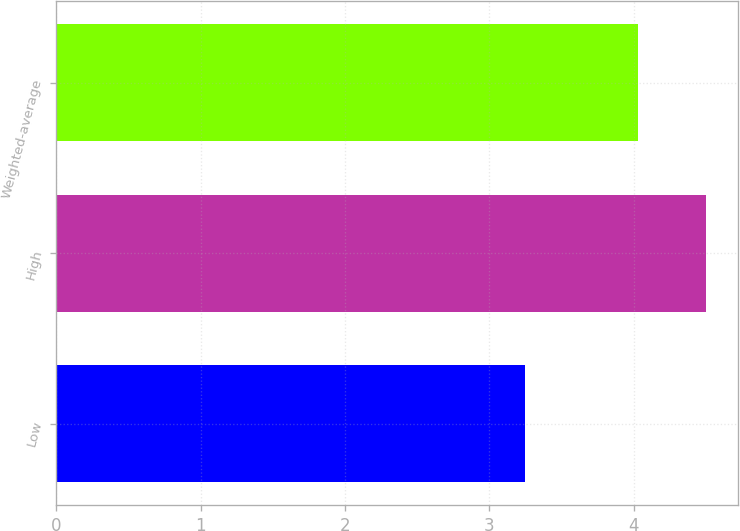Convert chart. <chart><loc_0><loc_0><loc_500><loc_500><bar_chart><fcel>Low<fcel>High<fcel>Weighted-average<nl><fcel>3.25<fcel>4.5<fcel>4.03<nl></chart> 